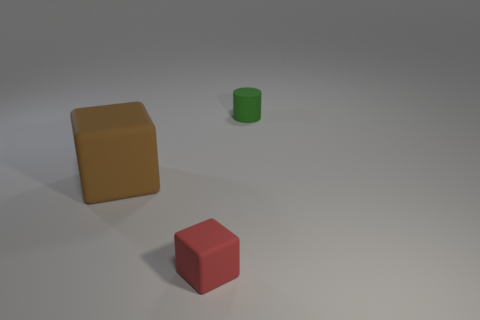What colors are the blocks in this image? The blocks in the image are yellow and red.  Are the blocks the same size? No, the blocks are not the same size. The yellow block is larger than the red block. 